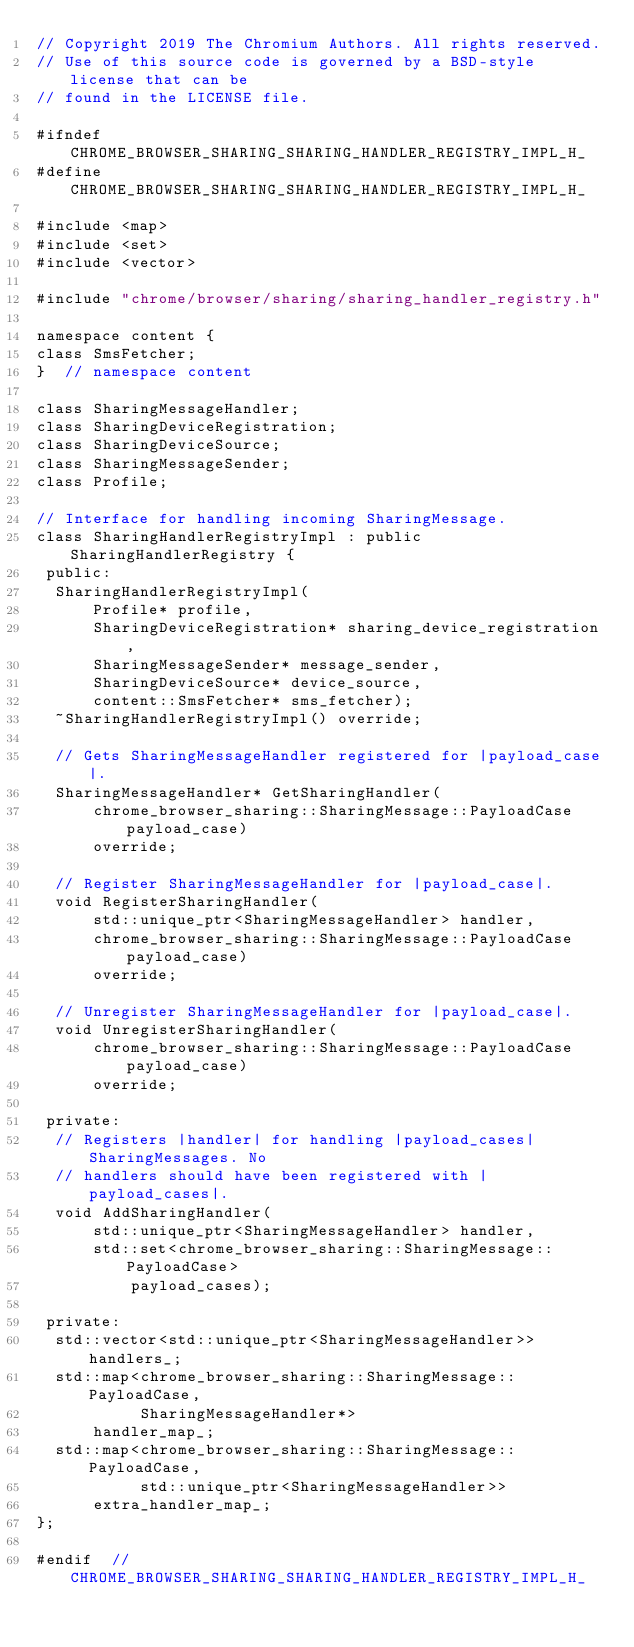Convert code to text. <code><loc_0><loc_0><loc_500><loc_500><_C_>// Copyright 2019 The Chromium Authors. All rights reserved.
// Use of this source code is governed by a BSD-style license that can be
// found in the LICENSE file.

#ifndef CHROME_BROWSER_SHARING_SHARING_HANDLER_REGISTRY_IMPL_H_
#define CHROME_BROWSER_SHARING_SHARING_HANDLER_REGISTRY_IMPL_H_

#include <map>
#include <set>
#include <vector>

#include "chrome/browser/sharing/sharing_handler_registry.h"

namespace content {
class SmsFetcher;
}  // namespace content

class SharingMessageHandler;
class SharingDeviceRegistration;
class SharingDeviceSource;
class SharingMessageSender;
class Profile;

// Interface for handling incoming SharingMessage.
class SharingHandlerRegistryImpl : public SharingHandlerRegistry {
 public:
  SharingHandlerRegistryImpl(
      Profile* profile,
      SharingDeviceRegistration* sharing_device_registration,
      SharingMessageSender* message_sender,
      SharingDeviceSource* device_source,
      content::SmsFetcher* sms_fetcher);
  ~SharingHandlerRegistryImpl() override;

  // Gets SharingMessageHandler registered for |payload_case|.
  SharingMessageHandler* GetSharingHandler(
      chrome_browser_sharing::SharingMessage::PayloadCase payload_case)
      override;

  // Register SharingMessageHandler for |payload_case|.
  void RegisterSharingHandler(
      std::unique_ptr<SharingMessageHandler> handler,
      chrome_browser_sharing::SharingMessage::PayloadCase payload_case)
      override;

  // Unregister SharingMessageHandler for |payload_case|.
  void UnregisterSharingHandler(
      chrome_browser_sharing::SharingMessage::PayloadCase payload_case)
      override;

 private:
  // Registers |handler| for handling |payload_cases| SharingMessages. No
  // handlers should have been registered with |payload_cases|.
  void AddSharingHandler(
      std::unique_ptr<SharingMessageHandler> handler,
      std::set<chrome_browser_sharing::SharingMessage::PayloadCase>
          payload_cases);

 private:
  std::vector<std::unique_ptr<SharingMessageHandler>> handlers_;
  std::map<chrome_browser_sharing::SharingMessage::PayloadCase,
           SharingMessageHandler*>
      handler_map_;
  std::map<chrome_browser_sharing::SharingMessage::PayloadCase,
           std::unique_ptr<SharingMessageHandler>>
      extra_handler_map_;
};

#endif  // CHROME_BROWSER_SHARING_SHARING_HANDLER_REGISTRY_IMPL_H_
</code> 